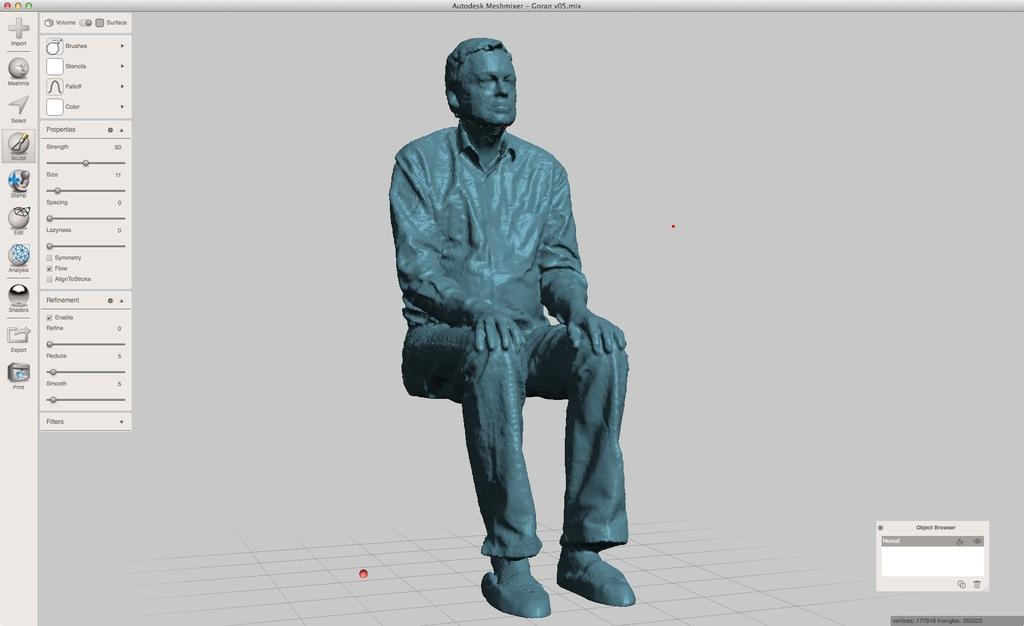What is the main object in the image? There is a computer screen in the image. What is displayed on the computer screen? There is a picture on the computer screen. What gate number is displayed on the computer screen? There is no gate number displayed on the computer screen; it only shows a picture. What type of roof can be seen on the computer screen? There is no roof visible on the computer screen; it only shows a picture. 